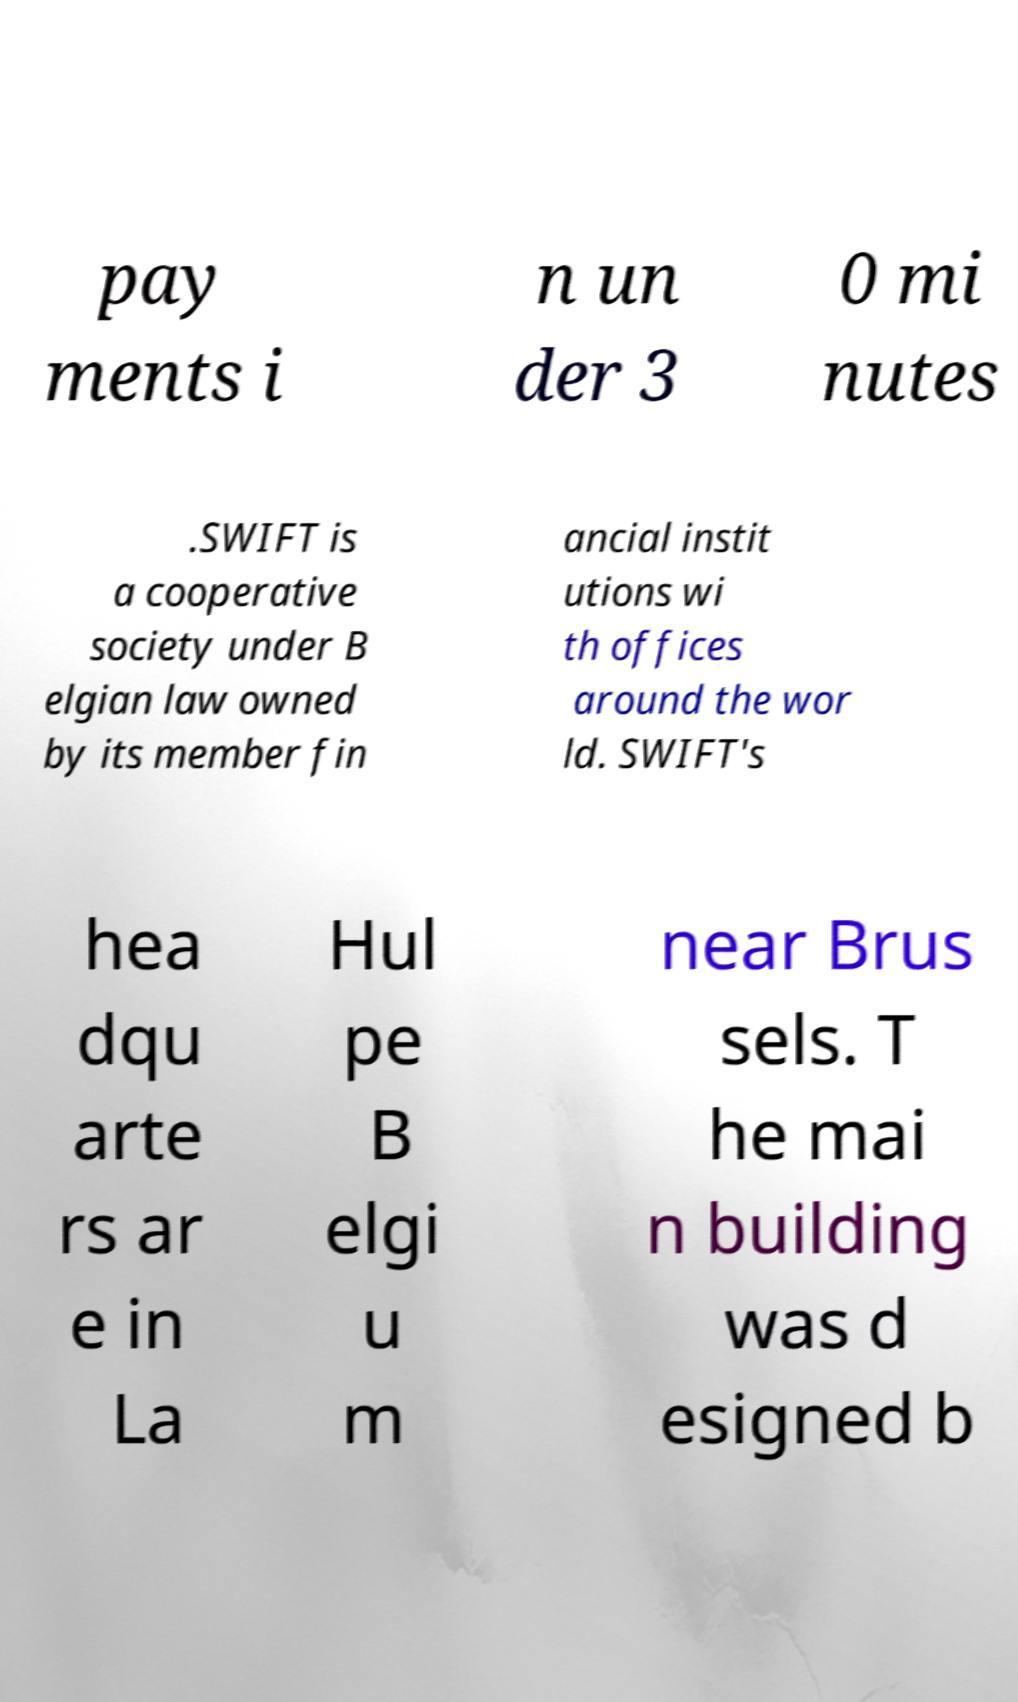There's text embedded in this image that I need extracted. Can you transcribe it verbatim? pay ments i n un der 3 0 mi nutes .SWIFT is a cooperative society under B elgian law owned by its member fin ancial instit utions wi th offices around the wor ld. SWIFT's hea dqu arte rs ar e in La Hul pe B elgi u m near Brus sels. T he mai n building was d esigned b 